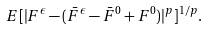Convert formula to latex. <formula><loc_0><loc_0><loc_500><loc_500>E [ | F ^ { \epsilon } - ( \bar { F } ^ { \epsilon } - \bar { F } ^ { 0 } + F ^ { 0 } ) | ^ { p } ] ^ { 1 / p } .</formula> 